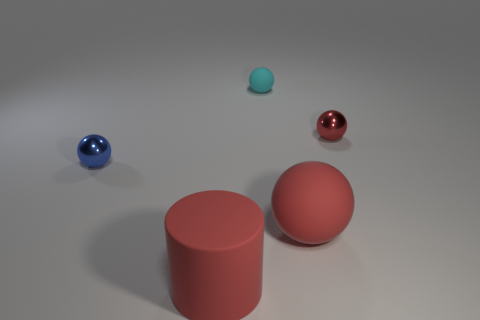Subtract all small red metal balls. How many balls are left? 3 Subtract 2 balls. How many balls are left? 2 Add 5 big red rubber balls. How many objects exist? 10 Subtract all yellow blocks. How many red balls are left? 2 Subtract all red balls. How many balls are left? 2 Subtract 1 cyan spheres. How many objects are left? 4 Subtract all spheres. How many objects are left? 1 Subtract all cyan cylinders. Subtract all red balls. How many cylinders are left? 1 Subtract all cylinders. Subtract all small yellow matte objects. How many objects are left? 4 Add 2 big red matte cylinders. How many big red matte cylinders are left? 3 